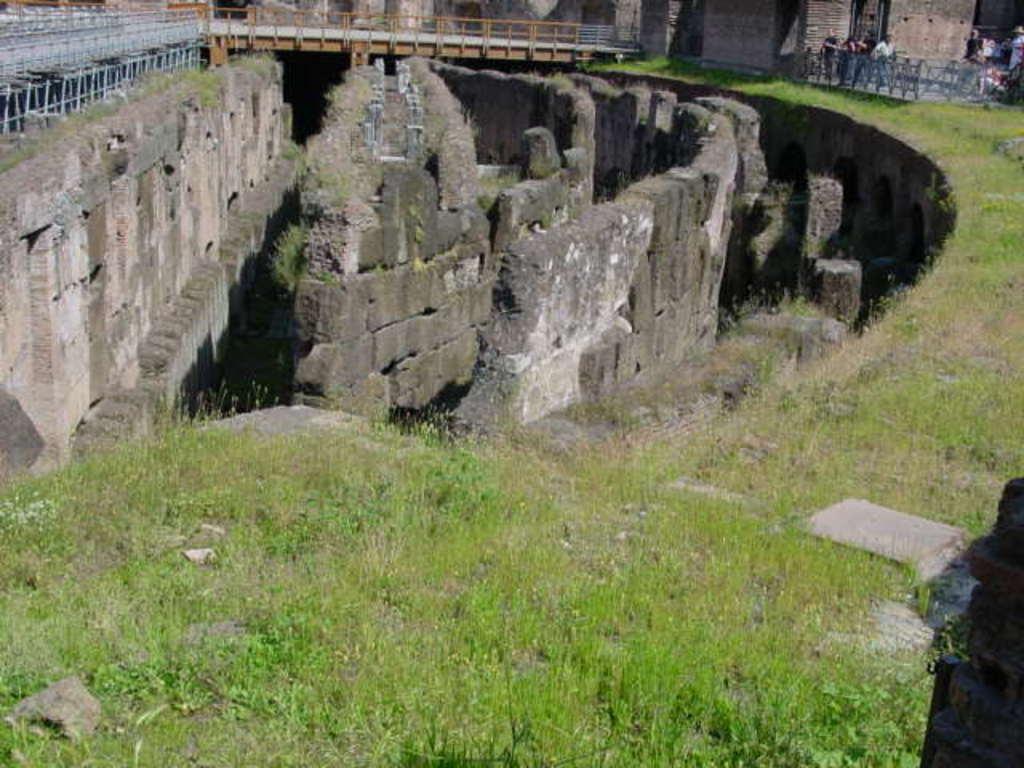In one or two sentences, can you explain what this image depicts? In this image in the front there's grass on the ground. In the center there are walls. In the background there is a bridge and on the right side there are persons standing and there is a wall. 